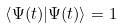<formula> <loc_0><loc_0><loc_500><loc_500>\left \langle { \Psi ( t ) | } \Psi ( t ) \right \rangle = 1</formula> 